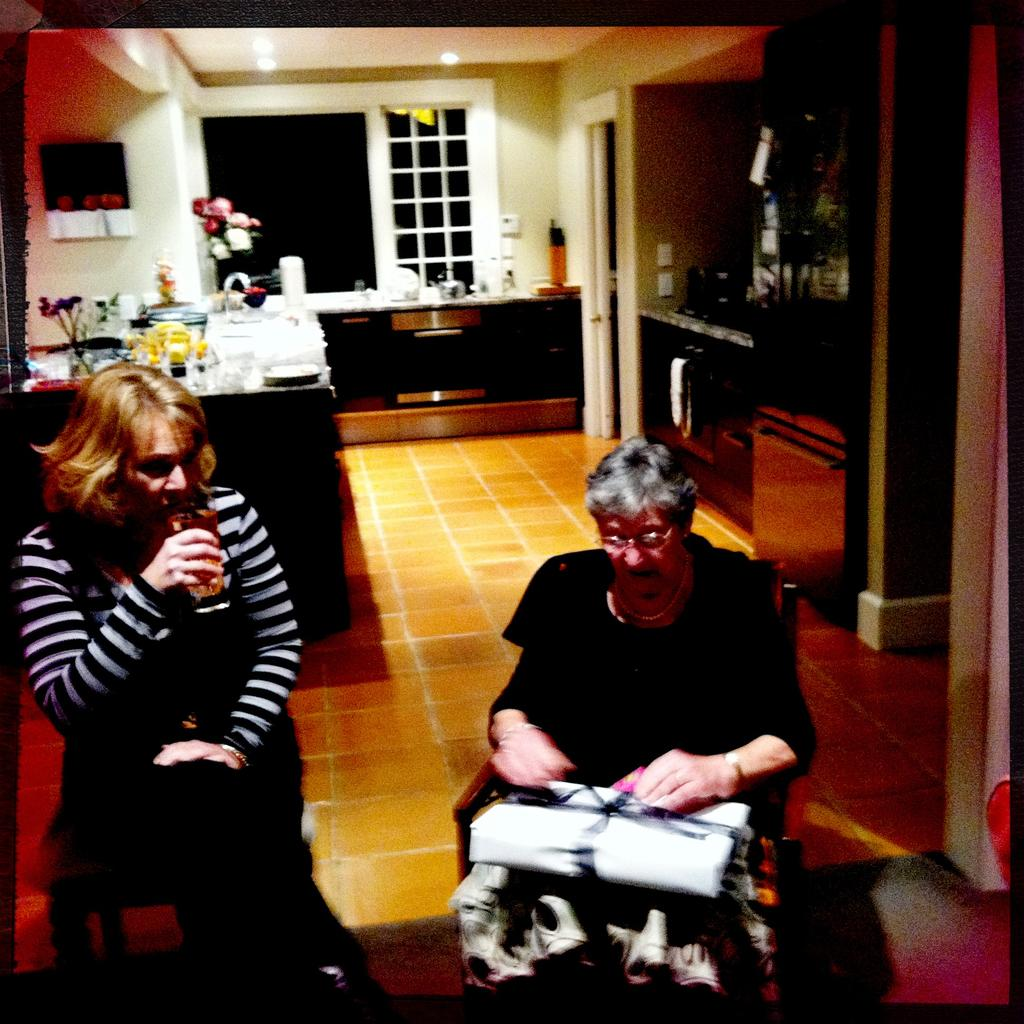How many people are in the image? There are two women in the image. What are the women doing in the image? The women are sitting on chairs. What is present in the image besides the women? There is a table in the image. What can be found on the table? There are objects on the table. What type of twig is being used by the laborer in the image? There is no laborer or twig present in the image. What color are the stockings worn by the women in the image? The provided facts do not mention the presence of stockings or their color. 